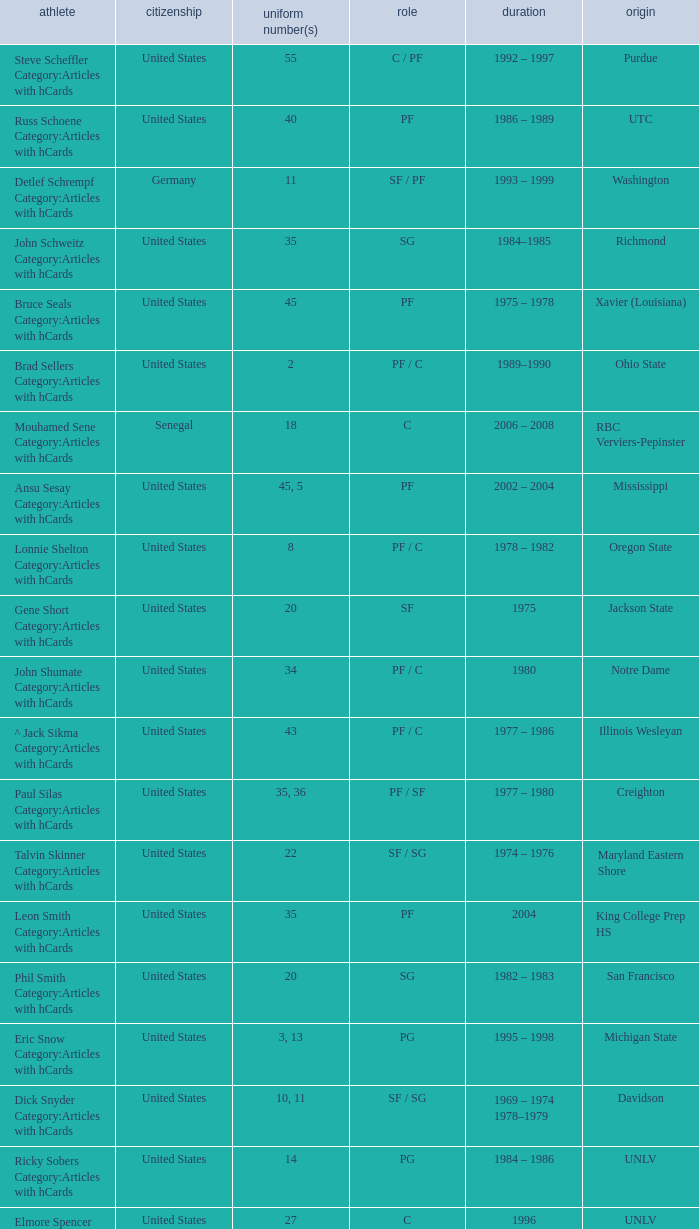Who wears the jersey number 20 and has the position of SG? Phil Smith Category:Articles with hCards, Jon Sundvold Category:Articles with hCards. Parse the full table. {'header': ['athlete', 'citizenship', 'uniform number(s)', 'role', 'duration', 'origin'], 'rows': [['Steve Scheffler Category:Articles with hCards', 'United States', '55', 'C / PF', '1992 – 1997', 'Purdue'], ['Russ Schoene Category:Articles with hCards', 'United States', '40', 'PF', '1986 – 1989', 'UTC'], ['Detlef Schrempf Category:Articles with hCards', 'Germany', '11', 'SF / PF', '1993 – 1999', 'Washington'], ['John Schweitz Category:Articles with hCards', 'United States', '35', 'SG', '1984–1985', 'Richmond'], ['Bruce Seals Category:Articles with hCards', 'United States', '45', 'PF', '1975 – 1978', 'Xavier (Louisiana)'], ['Brad Sellers Category:Articles with hCards', 'United States', '2', 'PF / C', '1989–1990', 'Ohio State'], ['Mouhamed Sene Category:Articles with hCards', 'Senegal', '18', 'C', '2006 – 2008', 'RBC Verviers-Pepinster'], ['Ansu Sesay Category:Articles with hCards', 'United States', '45, 5', 'PF', '2002 – 2004', 'Mississippi'], ['Lonnie Shelton Category:Articles with hCards', 'United States', '8', 'PF / C', '1978 – 1982', 'Oregon State'], ['Gene Short Category:Articles with hCards', 'United States', '20', 'SF', '1975', 'Jackson State'], ['John Shumate Category:Articles with hCards', 'United States', '34', 'PF / C', '1980', 'Notre Dame'], ['^ Jack Sikma Category:Articles with hCards', 'United States', '43', 'PF / C', '1977 – 1986', 'Illinois Wesleyan'], ['Paul Silas Category:Articles with hCards', 'United States', '35, 36', 'PF / SF', '1977 – 1980', 'Creighton'], ['Talvin Skinner Category:Articles with hCards', 'United States', '22', 'SF / SG', '1974 – 1976', 'Maryland Eastern Shore'], ['Leon Smith Category:Articles with hCards', 'United States', '35', 'PF', '2004', 'King College Prep HS'], ['Phil Smith Category:Articles with hCards', 'United States', '20', 'SG', '1982 – 1983', 'San Francisco'], ['Eric Snow Category:Articles with hCards', 'United States', '3, 13', 'PG', '1995 – 1998', 'Michigan State'], ['Dick Snyder Category:Articles with hCards', 'United States', '10, 11', 'SF / SG', '1969 – 1974 1978–1979', 'Davidson'], ['Ricky Sobers Category:Articles with hCards', 'United States', '14', 'PG', '1984 – 1986', 'UNLV'], ['Elmore Spencer Category:Articles with hCards', 'United States', '27', 'C', '1996', 'UNLV'], ['Isaac Stallworth Category:Articles with hCards', 'United States', '15', 'SF / SG', '1972 – 1974', 'Kansas'], ['Terence Stansbury Category:Articles with hCards', 'United States', '44', 'SG', '1986–1987', 'Temple'], ['Vladimir Stepania Category:Articles with hCards', 'Georgia', '5', 'Center', '1999 – 2000', 'KK Union Olimpija'], ['Larry Stewart Category:Articles with hCards', 'United States', '23', 'SF', '1996–1997', 'Coppin State'], ['Alex Stivrins Category:Articles with hCards', 'United States', '42', 'PF', '1985', 'Colorado'], ['Jon Sundvold Category:Articles with hCards', 'United States', '20', 'SG', '1984 – 1985', 'Missouri'], ['Robert Swift Category:Articles with hCards', 'United States', '31', 'C', '2005 – 2008', 'Bakersfield HS'], ['Wally Szczerbiak Category:Articles with hCards', 'United States', '3', 'SF / SG', '2007–2008', 'Miami (Ohio)']]} 